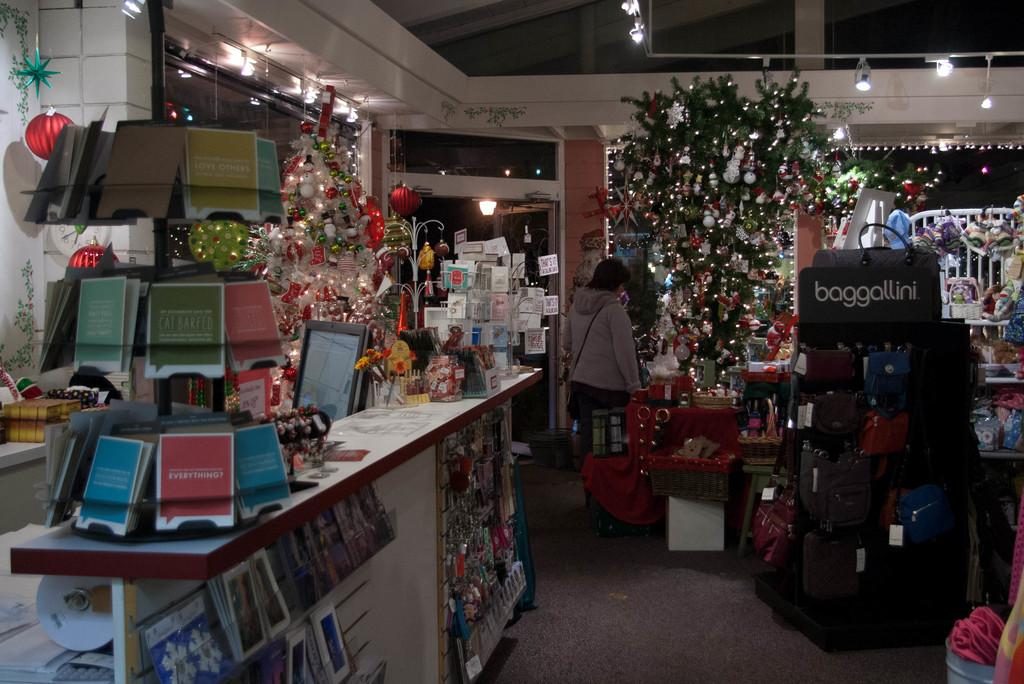<image>
Share a concise interpretation of the image provided. the inside of a store with a label on a purse rack that says 'baggallini' 